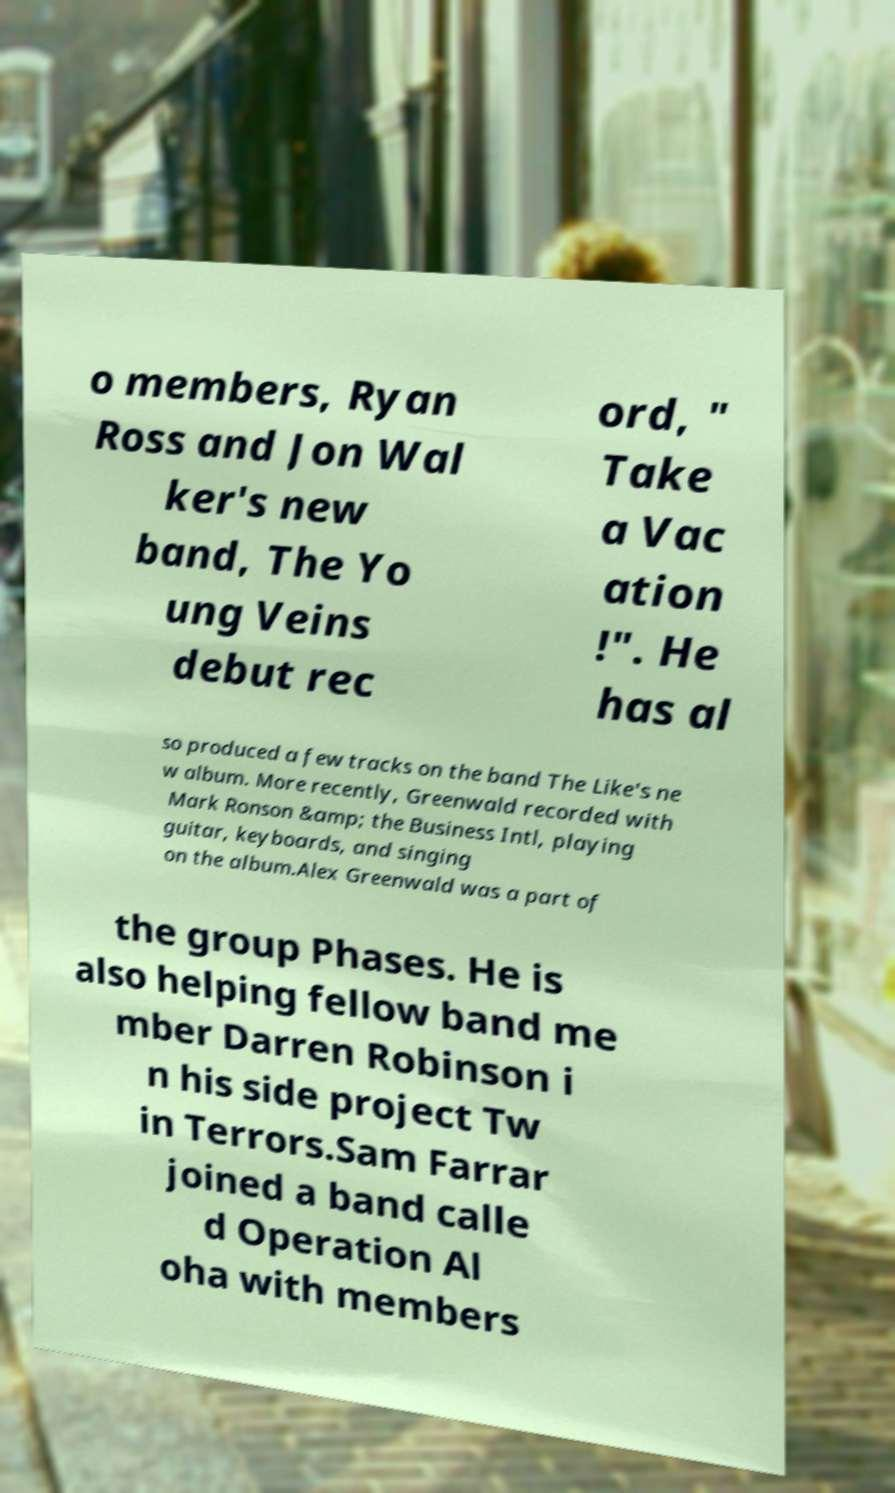For documentation purposes, I need the text within this image transcribed. Could you provide that? o members, Ryan Ross and Jon Wal ker's new band, The Yo ung Veins debut rec ord, " Take a Vac ation !". He has al so produced a few tracks on the band The Like's ne w album. More recently, Greenwald recorded with Mark Ronson &amp; the Business Intl, playing guitar, keyboards, and singing on the album.Alex Greenwald was a part of the group Phases. He is also helping fellow band me mber Darren Robinson i n his side project Tw in Terrors.Sam Farrar joined a band calle d Operation Al oha with members 